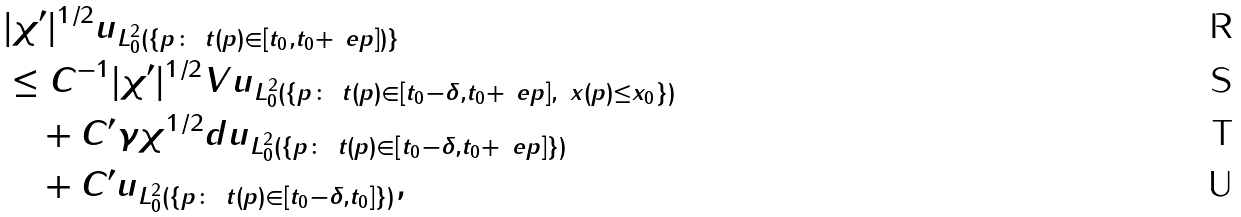<formula> <loc_0><loc_0><loc_500><loc_500>& \| | \chi ^ { \prime } | ^ { 1 / 2 } u \| _ { L ^ { 2 } _ { 0 } ( \{ p \colon \ t ( p ) \in [ t _ { 0 } , t _ { 0 } + \ e p ] ) \} } \\ & \leq C ^ { - 1 } \| | \chi ^ { \prime } | ^ { 1 / 2 } V u \| _ { L ^ { 2 } _ { 0 } ( \{ p \colon \ t ( p ) \in [ t _ { 0 } - \delta , t _ { 0 } + \ e p ] , \ x ( p ) \leq x _ { 0 } \} ) } \\ & \quad + C ^ { \prime } \gamma \| \chi ^ { 1 / 2 } d u \| _ { L ^ { 2 } _ { 0 } ( \{ p \colon \ t ( p ) \in [ t _ { 0 } - \delta , t _ { 0 } + \ e p ] \} ) } \\ & \quad + C ^ { \prime } \| u \| _ { L ^ { 2 } _ { 0 } ( \{ p \colon \ t ( p ) \in [ t _ { 0 } - \delta , t _ { 0 } ] \} ) } ,</formula> 